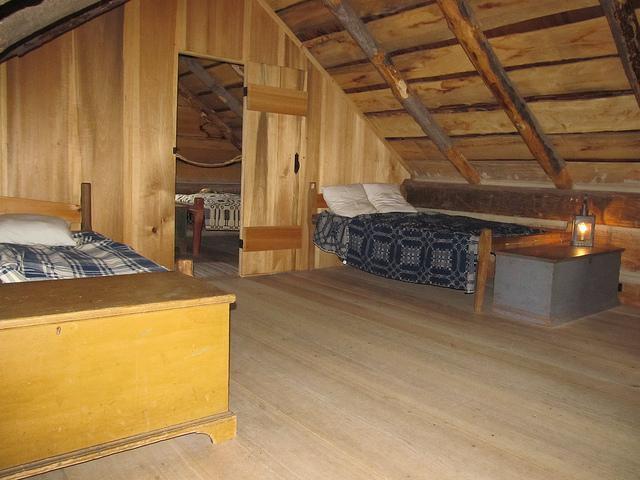What color of light is emanated by the lantern on the top of the footlocker?
Indicate the correct response by choosing from the four available options to answer the question.
Options: Orange, black, white, pink. Orange. 